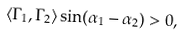Convert formula to latex. <formula><loc_0><loc_0><loc_500><loc_500>\langle \Gamma _ { 1 } , \Gamma _ { 2 } \rangle \sin ( \alpha _ { 1 } - \alpha _ { 2 } ) > 0 ,</formula> 